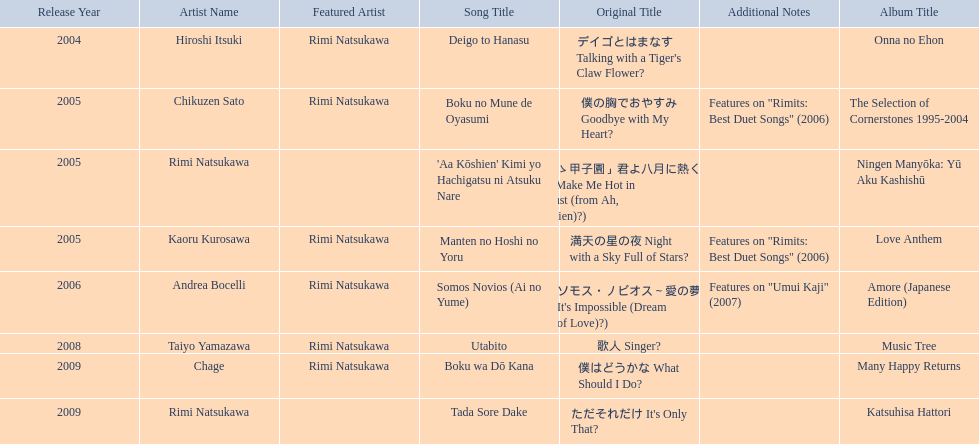When was onna no ehon released? 2004. When was the selection of cornerstones 1995-2004 released? 2005. Could you parse the entire table as a dict? {'header': ['Release Year', 'Artist Name', 'Featured Artist', 'Song Title', 'Original Title', 'Additional Notes', 'Album Title'], 'rows': [['2004', 'Hiroshi Itsuki', 'Rimi Natsukawa', 'Deigo to Hanasu', "デイゴとはまなす Talking with a Tiger's Claw Flower?", '', 'Onna no Ehon'], ['2005', 'Chikuzen Sato', 'Rimi Natsukawa', 'Boku no Mune de Oyasumi', '僕の胸でおやすみ Goodbye with My Heart?', 'Features on "Rimits: Best Duet Songs" (2006)', 'The Selection of Cornerstones 1995-2004'], ['2005', 'Rimi Natsukawa', '', "'Aa Kōshien' Kimi yo Hachigatsu ni Atsuku Nare", '「あゝ甲子園」君よ八月に熱くなれ You Make Me Hot in August (from Ah, Kōshien)?)', '', 'Ningen Manyōka: Yū Aku Kashishū'], ['2005', 'Kaoru Kurosawa', 'Rimi Natsukawa', 'Manten no Hoshi no Yoru', '満天の星の夜 Night with a Sky Full of Stars?', 'Features on "Rimits: Best Duet Songs" (2006)', 'Love Anthem'], ['2006', 'Andrea Bocelli', 'Rimi Natsukawa', 'Somos Novios (Ai no Yume)', "ソモス・ノビオス～愛の夢 It's Impossible (Dream of Love)?)", 'Features on "Umui Kaji" (2007)', 'Amore (Japanese Edition)'], ['2008', 'Taiyo Yamazawa', 'Rimi Natsukawa', 'Utabito', '歌人 Singer?', '', 'Music Tree'], ['2009', 'Chage', 'Rimi Natsukawa', 'Boku wa Dō Kana', '僕はどうかな What Should I Do?', '', 'Many Happy Returns'], ['2009', 'Rimi Natsukawa', '', 'Tada Sore Dake', "ただそれだけ It's Only That?", '', 'Katsuhisa Hattori']]} What was released in 2008? Music Tree. 